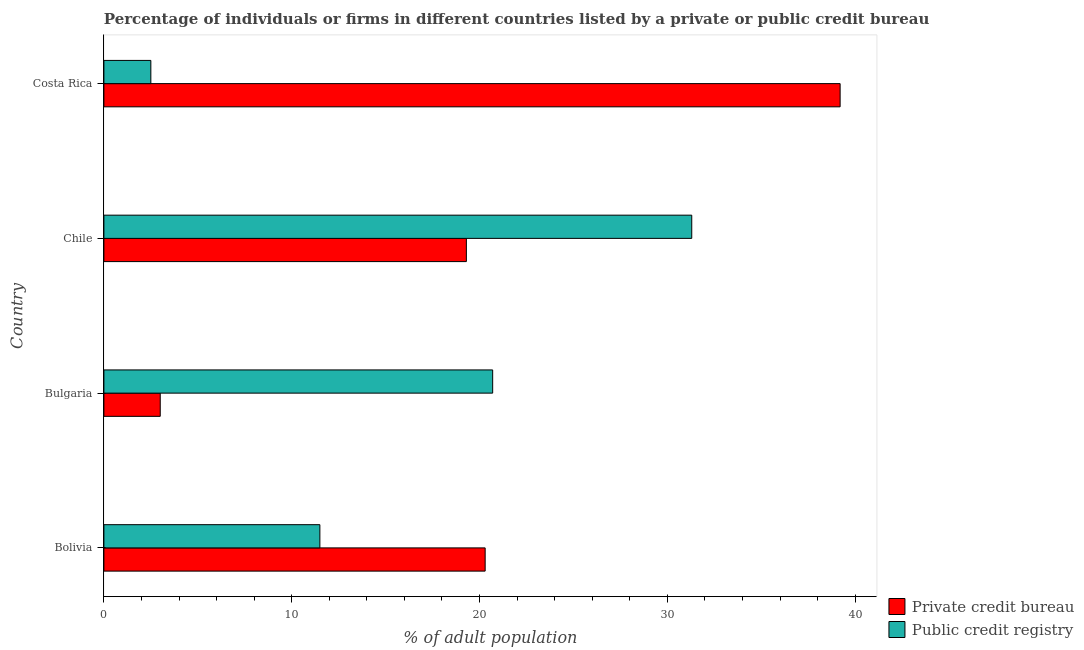How many different coloured bars are there?
Give a very brief answer. 2. Are the number of bars on each tick of the Y-axis equal?
Ensure brevity in your answer.  Yes. In how many cases, is the number of bars for a given country not equal to the number of legend labels?
Your answer should be very brief. 0. What is the percentage of firms listed by private credit bureau in Bulgaria?
Keep it short and to the point. 3. Across all countries, what is the maximum percentage of firms listed by public credit bureau?
Ensure brevity in your answer.  31.3. What is the difference between the percentage of firms listed by private credit bureau in Bulgaria and that in Chile?
Offer a terse response. -16.3. What is the difference between the percentage of firms listed by private credit bureau in Costa Rica and the percentage of firms listed by public credit bureau in Bulgaria?
Offer a very short reply. 18.5. What is the difference between the percentage of firms listed by private credit bureau and percentage of firms listed by public credit bureau in Bulgaria?
Give a very brief answer. -17.7. What is the ratio of the percentage of firms listed by private credit bureau in Chile to that in Costa Rica?
Provide a succinct answer. 0.49. What is the difference between the highest and the lowest percentage of firms listed by public credit bureau?
Provide a succinct answer. 28.8. Is the sum of the percentage of firms listed by public credit bureau in Bolivia and Chile greater than the maximum percentage of firms listed by private credit bureau across all countries?
Your answer should be very brief. Yes. What does the 2nd bar from the top in Chile represents?
Keep it short and to the point. Private credit bureau. What does the 2nd bar from the bottom in Bolivia represents?
Give a very brief answer. Public credit registry. How many bars are there?
Offer a very short reply. 8. Are all the bars in the graph horizontal?
Keep it short and to the point. Yes. Does the graph contain any zero values?
Provide a succinct answer. No. Does the graph contain grids?
Keep it short and to the point. No. Where does the legend appear in the graph?
Your answer should be very brief. Bottom right. How are the legend labels stacked?
Provide a succinct answer. Vertical. What is the title of the graph?
Keep it short and to the point. Percentage of individuals or firms in different countries listed by a private or public credit bureau. What is the label or title of the X-axis?
Keep it short and to the point. % of adult population. What is the label or title of the Y-axis?
Provide a succinct answer. Country. What is the % of adult population of Private credit bureau in Bolivia?
Make the answer very short. 20.3. What is the % of adult population in Public credit registry in Bolivia?
Make the answer very short. 11.5. What is the % of adult population in Private credit bureau in Bulgaria?
Your response must be concise. 3. What is the % of adult population of Public credit registry in Bulgaria?
Provide a short and direct response. 20.7. What is the % of adult population of Private credit bureau in Chile?
Ensure brevity in your answer.  19.3. What is the % of adult population of Public credit registry in Chile?
Provide a short and direct response. 31.3. What is the % of adult population in Private credit bureau in Costa Rica?
Offer a terse response. 39.2. Across all countries, what is the maximum % of adult population in Private credit bureau?
Offer a very short reply. 39.2. Across all countries, what is the maximum % of adult population in Public credit registry?
Keep it short and to the point. 31.3. What is the total % of adult population in Private credit bureau in the graph?
Provide a short and direct response. 81.8. What is the difference between the % of adult population in Public credit registry in Bolivia and that in Bulgaria?
Your answer should be compact. -9.2. What is the difference between the % of adult population in Public credit registry in Bolivia and that in Chile?
Your answer should be compact. -19.8. What is the difference between the % of adult population in Private credit bureau in Bolivia and that in Costa Rica?
Give a very brief answer. -18.9. What is the difference between the % of adult population in Public credit registry in Bolivia and that in Costa Rica?
Ensure brevity in your answer.  9. What is the difference between the % of adult population of Private credit bureau in Bulgaria and that in Chile?
Your response must be concise. -16.3. What is the difference between the % of adult population in Private credit bureau in Bulgaria and that in Costa Rica?
Ensure brevity in your answer.  -36.2. What is the difference between the % of adult population of Private credit bureau in Chile and that in Costa Rica?
Your answer should be very brief. -19.9. What is the difference between the % of adult population of Public credit registry in Chile and that in Costa Rica?
Keep it short and to the point. 28.8. What is the difference between the % of adult population in Private credit bureau in Bolivia and the % of adult population in Public credit registry in Chile?
Give a very brief answer. -11. What is the difference between the % of adult population of Private credit bureau in Bulgaria and the % of adult population of Public credit registry in Chile?
Your response must be concise. -28.3. What is the difference between the % of adult population in Private credit bureau in Chile and the % of adult population in Public credit registry in Costa Rica?
Ensure brevity in your answer.  16.8. What is the average % of adult population in Private credit bureau per country?
Provide a short and direct response. 20.45. What is the difference between the % of adult population of Private credit bureau and % of adult population of Public credit registry in Bulgaria?
Your answer should be very brief. -17.7. What is the difference between the % of adult population in Private credit bureau and % of adult population in Public credit registry in Chile?
Give a very brief answer. -12. What is the difference between the % of adult population in Private credit bureau and % of adult population in Public credit registry in Costa Rica?
Your answer should be very brief. 36.7. What is the ratio of the % of adult population in Private credit bureau in Bolivia to that in Bulgaria?
Your answer should be compact. 6.77. What is the ratio of the % of adult population of Public credit registry in Bolivia to that in Bulgaria?
Your answer should be compact. 0.56. What is the ratio of the % of adult population in Private credit bureau in Bolivia to that in Chile?
Give a very brief answer. 1.05. What is the ratio of the % of adult population in Public credit registry in Bolivia to that in Chile?
Keep it short and to the point. 0.37. What is the ratio of the % of adult population in Private credit bureau in Bolivia to that in Costa Rica?
Offer a very short reply. 0.52. What is the ratio of the % of adult population of Private credit bureau in Bulgaria to that in Chile?
Your answer should be very brief. 0.16. What is the ratio of the % of adult population in Public credit registry in Bulgaria to that in Chile?
Provide a short and direct response. 0.66. What is the ratio of the % of adult population of Private credit bureau in Bulgaria to that in Costa Rica?
Your answer should be compact. 0.08. What is the ratio of the % of adult population in Public credit registry in Bulgaria to that in Costa Rica?
Your answer should be very brief. 8.28. What is the ratio of the % of adult population in Private credit bureau in Chile to that in Costa Rica?
Give a very brief answer. 0.49. What is the ratio of the % of adult population in Public credit registry in Chile to that in Costa Rica?
Keep it short and to the point. 12.52. What is the difference between the highest and the second highest % of adult population in Private credit bureau?
Offer a very short reply. 18.9. What is the difference between the highest and the second highest % of adult population in Public credit registry?
Your answer should be very brief. 10.6. What is the difference between the highest and the lowest % of adult population of Private credit bureau?
Your response must be concise. 36.2. What is the difference between the highest and the lowest % of adult population in Public credit registry?
Offer a very short reply. 28.8. 